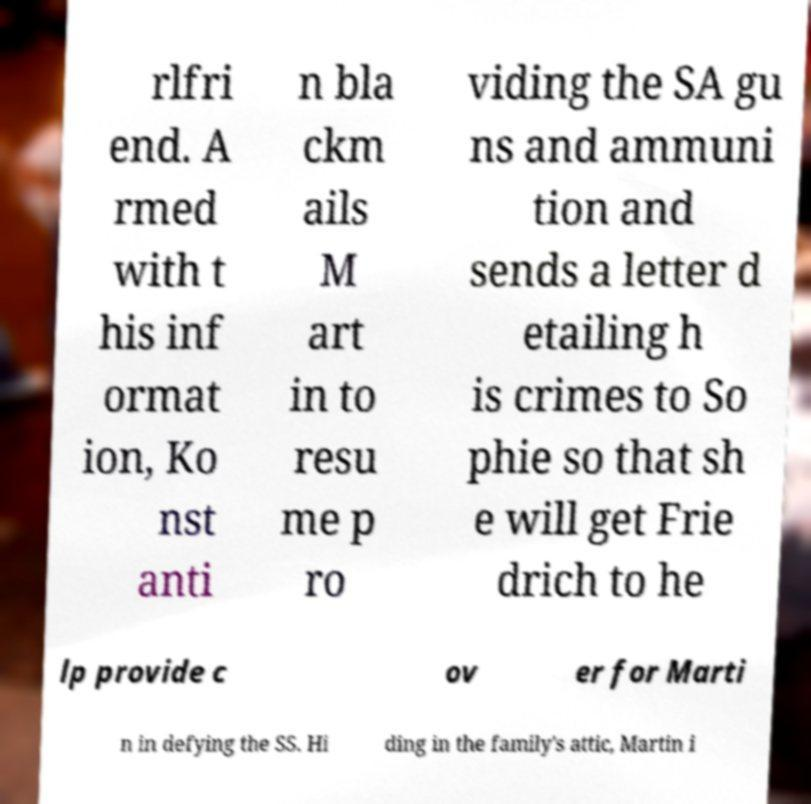What messages or text are displayed in this image? I need them in a readable, typed format. rlfri end. A rmed with t his inf ormat ion, Ko nst anti n bla ckm ails M art in to resu me p ro viding the SA gu ns and ammuni tion and sends a letter d etailing h is crimes to So phie so that sh e will get Frie drich to he lp provide c ov er for Marti n in defying the SS. Hi ding in the family's attic, Martin i 